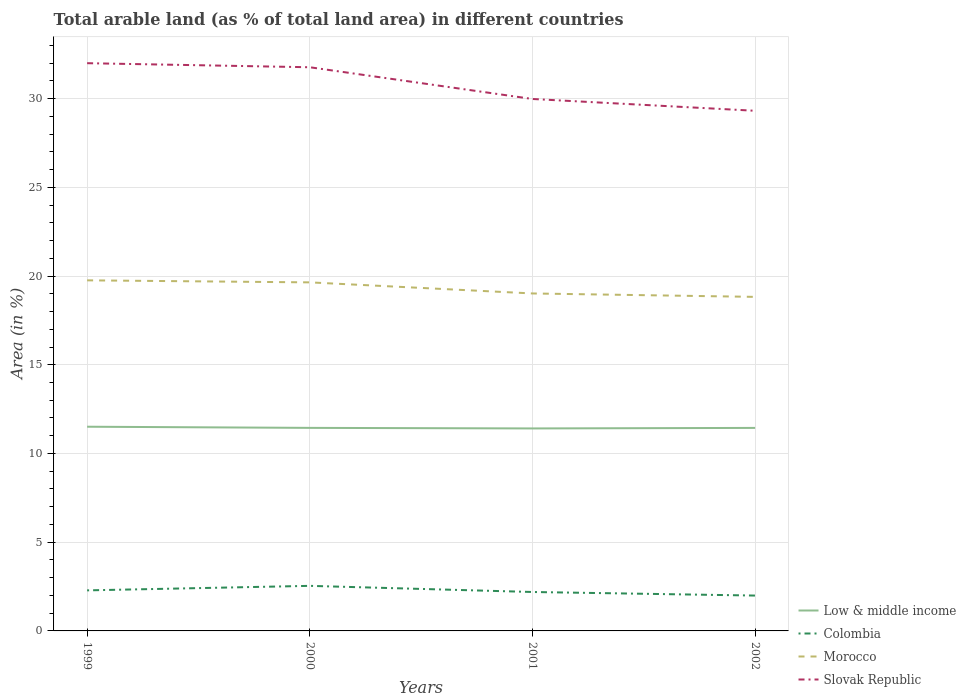How many different coloured lines are there?
Your answer should be compact. 4. Across all years, what is the maximum percentage of arable land in Slovak Republic?
Your response must be concise. 29.31. In which year was the percentage of arable land in Low & middle income maximum?
Give a very brief answer. 2001. What is the total percentage of arable land in Morocco in the graph?
Give a very brief answer. 0.93. What is the difference between the highest and the second highest percentage of arable land in Slovak Republic?
Your response must be concise. 2.68. How many lines are there?
Provide a succinct answer. 4. What is the difference between two consecutive major ticks on the Y-axis?
Offer a terse response. 5. Does the graph contain any zero values?
Provide a short and direct response. No. Does the graph contain grids?
Ensure brevity in your answer.  Yes. How are the legend labels stacked?
Offer a very short reply. Vertical. What is the title of the graph?
Your answer should be compact. Total arable land (as % of total land area) in different countries. Does "Lithuania" appear as one of the legend labels in the graph?
Your response must be concise. No. What is the label or title of the Y-axis?
Your response must be concise. Area (in %). What is the Area (in %) in Low & middle income in 1999?
Provide a short and direct response. 11.51. What is the Area (in %) in Colombia in 1999?
Provide a succinct answer. 2.29. What is the Area (in %) in Morocco in 1999?
Your response must be concise. 19.76. What is the Area (in %) in Slovak Republic in 1999?
Your response must be concise. 32. What is the Area (in %) in Low & middle income in 2000?
Your answer should be compact. 11.44. What is the Area (in %) in Colombia in 2000?
Your answer should be very brief. 2.54. What is the Area (in %) of Morocco in 2000?
Provide a succinct answer. 19.64. What is the Area (in %) of Slovak Republic in 2000?
Your response must be concise. 31.77. What is the Area (in %) of Low & middle income in 2001?
Keep it short and to the point. 11.41. What is the Area (in %) in Colombia in 2001?
Make the answer very short. 2.19. What is the Area (in %) of Morocco in 2001?
Provide a short and direct response. 19.02. What is the Area (in %) in Slovak Republic in 2001?
Offer a terse response. 29.98. What is the Area (in %) in Low & middle income in 2002?
Keep it short and to the point. 11.44. What is the Area (in %) in Colombia in 2002?
Your answer should be very brief. 1.99. What is the Area (in %) of Morocco in 2002?
Give a very brief answer. 18.83. What is the Area (in %) in Slovak Republic in 2002?
Offer a terse response. 29.31. Across all years, what is the maximum Area (in %) of Low & middle income?
Your response must be concise. 11.51. Across all years, what is the maximum Area (in %) of Colombia?
Offer a very short reply. 2.54. Across all years, what is the maximum Area (in %) in Morocco?
Provide a short and direct response. 19.76. Across all years, what is the maximum Area (in %) in Slovak Republic?
Give a very brief answer. 32. Across all years, what is the minimum Area (in %) of Low & middle income?
Offer a terse response. 11.41. Across all years, what is the minimum Area (in %) of Colombia?
Provide a short and direct response. 1.99. Across all years, what is the minimum Area (in %) of Morocco?
Make the answer very short. 18.83. Across all years, what is the minimum Area (in %) in Slovak Republic?
Offer a very short reply. 29.31. What is the total Area (in %) in Low & middle income in the graph?
Provide a short and direct response. 45.8. What is the total Area (in %) of Colombia in the graph?
Make the answer very short. 9.01. What is the total Area (in %) in Morocco in the graph?
Offer a very short reply. 77.25. What is the total Area (in %) in Slovak Republic in the graph?
Offer a very short reply. 123.06. What is the difference between the Area (in %) in Low & middle income in 1999 and that in 2000?
Your answer should be very brief. 0.06. What is the difference between the Area (in %) of Colombia in 1999 and that in 2000?
Offer a terse response. -0.25. What is the difference between the Area (in %) of Morocco in 1999 and that in 2000?
Offer a very short reply. 0.11. What is the difference between the Area (in %) in Slovak Republic in 1999 and that in 2000?
Your response must be concise. 0.23. What is the difference between the Area (in %) in Low & middle income in 1999 and that in 2001?
Your answer should be compact. 0.1. What is the difference between the Area (in %) of Colombia in 1999 and that in 2001?
Your response must be concise. 0.09. What is the difference between the Area (in %) of Morocco in 1999 and that in 2001?
Your answer should be compact. 0.74. What is the difference between the Area (in %) in Slovak Republic in 1999 and that in 2001?
Offer a very short reply. 2.02. What is the difference between the Area (in %) of Low & middle income in 1999 and that in 2002?
Your response must be concise. 0.07. What is the difference between the Area (in %) in Colombia in 1999 and that in 2002?
Make the answer very short. 0.29. What is the difference between the Area (in %) in Morocco in 1999 and that in 2002?
Offer a terse response. 0.93. What is the difference between the Area (in %) in Slovak Republic in 1999 and that in 2002?
Ensure brevity in your answer.  2.68. What is the difference between the Area (in %) in Low & middle income in 2000 and that in 2001?
Provide a succinct answer. 0.03. What is the difference between the Area (in %) in Colombia in 2000 and that in 2001?
Ensure brevity in your answer.  0.35. What is the difference between the Area (in %) of Morocco in 2000 and that in 2001?
Give a very brief answer. 0.63. What is the difference between the Area (in %) in Slovak Republic in 2000 and that in 2001?
Offer a very short reply. 1.79. What is the difference between the Area (in %) in Low & middle income in 2000 and that in 2002?
Provide a succinct answer. 0. What is the difference between the Area (in %) of Colombia in 2000 and that in 2002?
Your response must be concise. 0.55. What is the difference between the Area (in %) of Morocco in 2000 and that in 2002?
Offer a very short reply. 0.82. What is the difference between the Area (in %) of Slovak Republic in 2000 and that in 2002?
Offer a terse response. 2.45. What is the difference between the Area (in %) in Low & middle income in 2001 and that in 2002?
Offer a terse response. -0.03. What is the difference between the Area (in %) in Colombia in 2001 and that in 2002?
Your response must be concise. 0.2. What is the difference between the Area (in %) in Morocco in 2001 and that in 2002?
Your answer should be compact. 0.19. What is the difference between the Area (in %) in Slovak Republic in 2001 and that in 2002?
Your answer should be very brief. 0.67. What is the difference between the Area (in %) in Low & middle income in 1999 and the Area (in %) in Colombia in 2000?
Provide a succinct answer. 8.97. What is the difference between the Area (in %) of Low & middle income in 1999 and the Area (in %) of Morocco in 2000?
Keep it short and to the point. -8.14. What is the difference between the Area (in %) in Low & middle income in 1999 and the Area (in %) in Slovak Republic in 2000?
Offer a terse response. -20.26. What is the difference between the Area (in %) in Colombia in 1999 and the Area (in %) in Morocco in 2000?
Ensure brevity in your answer.  -17.36. What is the difference between the Area (in %) in Colombia in 1999 and the Area (in %) in Slovak Republic in 2000?
Your answer should be compact. -29.48. What is the difference between the Area (in %) of Morocco in 1999 and the Area (in %) of Slovak Republic in 2000?
Provide a succinct answer. -12.01. What is the difference between the Area (in %) in Low & middle income in 1999 and the Area (in %) in Colombia in 2001?
Ensure brevity in your answer.  9.31. What is the difference between the Area (in %) in Low & middle income in 1999 and the Area (in %) in Morocco in 2001?
Make the answer very short. -7.51. What is the difference between the Area (in %) in Low & middle income in 1999 and the Area (in %) in Slovak Republic in 2001?
Your answer should be very brief. -18.47. What is the difference between the Area (in %) of Colombia in 1999 and the Area (in %) of Morocco in 2001?
Provide a short and direct response. -16.73. What is the difference between the Area (in %) of Colombia in 1999 and the Area (in %) of Slovak Republic in 2001?
Keep it short and to the point. -27.69. What is the difference between the Area (in %) in Morocco in 1999 and the Area (in %) in Slovak Republic in 2001?
Offer a terse response. -10.22. What is the difference between the Area (in %) in Low & middle income in 1999 and the Area (in %) in Colombia in 2002?
Your answer should be compact. 9.52. What is the difference between the Area (in %) of Low & middle income in 1999 and the Area (in %) of Morocco in 2002?
Provide a succinct answer. -7.32. What is the difference between the Area (in %) in Low & middle income in 1999 and the Area (in %) in Slovak Republic in 2002?
Your answer should be compact. -17.81. What is the difference between the Area (in %) in Colombia in 1999 and the Area (in %) in Morocco in 2002?
Make the answer very short. -16.54. What is the difference between the Area (in %) of Colombia in 1999 and the Area (in %) of Slovak Republic in 2002?
Provide a short and direct response. -27.03. What is the difference between the Area (in %) of Morocco in 1999 and the Area (in %) of Slovak Republic in 2002?
Offer a terse response. -9.56. What is the difference between the Area (in %) in Low & middle income in 2000 and the Area (in %) in Colombia in 2001?
Give a very brief answer. 9.25. What is the difference between the Area (in %) in Low & middle income in 2000 and the Area (in %) in Morocco in 2001?
Keep it short and to the point. -7.58. What is the difference between the Area (in %) of Low & middle income in 2000 and the Area (in %) of Slovak Republic in 2001?
Give a very brief answer. -18.54. What is the difference between the Area (in %) in Colombia in 2000 and the Area (in %) in Morocco in 2001?
Give a very brief answer. -16.48. What is the difference between the Area (in %) in Colombia in 2000 and the Area (in %) in Slovak Republic in 2001?
Provide a succinct answer. -27.44. What is the difference between the Area (in %) in Morocco in 2000 and the Area (in %) in Slovak Republic in 2001?
Your answer should be very brief. -10.34. What is the difference between the Area (in %) of Low & middle income in 2000 and the Area (in %) of Colombia in 2002?
Give a very brief answer. 9.45. What is the difference between the Area (in %) in Low & middle income in 2000 and the Area (in %) in Morocco in 2002?
Offer a terse response. -7.38. What is the difference between the Area (in %) in Low & middle income in 2000 and the Area (in %) in Slovak Republic in 2002?
Ensure brevity in your answer.  -17.87. What is the difference between the Area (in %) of Colombia in 2000 and the Area (in %) of Morocco in 2002?
Keep it short and to the point. -16.29. What is the difference between the Area (in %) of Colombia in 2000 and the Area (in %) of Slovak Republic in 2002?
Your answer should be compact. -26.77. What is the difference between the Area (in %) of Morocco in 2000 and the Area (in %) of Slovak Republic in 2002?
Your answer should be compact. -9.67. What is the difference between the Area (in %) in Low & middle income in 2001 and the Area (in %) in Colombia in 2002?
Your response must be concise. 9.42. What is the difference between the Area (in %) of Low & middle income in 2001 and the Area (in %) of Morocco in 2002?
Your answer should be very brief. -7.41. What is the difference between the Area (in %) in Low & middle income in 2001 and the Area (in %) in Slovak Republic in 2002?
Offer a terse response. -17.9. What is the difference between the Area (in %) of Colombia in 2001 and the Area (in %) of Morocco in 2002?
Give a very brief answer. -16.63. What is the difference between the Area (in %) in Colombia in 2001 and the Area (in %) in Slovak Republic in 2002?
Give a very brief answer. -27.12. What is the difference between the Area (in %) of Morocco in 2001 and the Area (in %) of Slovak Republic in 2002?
Provide a short and direct response. -10.3. What is the average Area (in %) in Low & middle income per year?
Give a very brief answer. 11.45. What is the average Area (in %) of Colombia per year?
Give a very brief answer. 2.25. What is the average Area (in %) of Morocco per year?
Offer a very short reply. 19.31. What is the average Area (in %) of Slovak Republic per year?
Keep it short and to the point. 30.76. In the year 1999, what is the difference between the Area (in %) in Low & middle income and Area (in %) in Colombia?
Your response must be concise. 9.22. In the year 1999, what is the difference between the Area (in %) in Low & middle income and Area (in %) in Morocco?
Offer a very short reply. -8.25. In the year 1999, what is the difference between the Area (in %) in Low & middle income and Area (in %) in Slovak Republic?
Offer a terse response. -20.49. In the year 1999, what is the difference between the Area (in %) of Colombia and Area (in %) of Morocco?
Offer a terse response. -17.47. In the year 1999, what is the difference between the Area (in %) in Colombia and Area (in %) in Slovak Republic?
Your answer should be very brief. -29.71. In the year 1999, what is the difference between the Area (in %) of Morocco and Area (in %) of Slovak Republic?
Ensure brevity in your answer.  -12.24. In the year 2000, what is the difference between the Area (in %) of Low & middle income and Area (in %) of Colombia?
Ensure brevity in your answer.  8.9. In the year 2000, what is the difference between the Area (in %) in Low & middle income and Area (in %) in Morocco?
Your response must be concise. -8.2. In the year 2000, what is the difference between the Area (in %) of Low & middle income and Area (in %) of Slovak Republic?
Provide a short and direct response. -20.32. In the year 2000, what is the difference between the Area (in %) of Colombia and Area (in %) of Morocco?
Keep it short and to the point. -17.1. In the year 2000, what is the difference between the Area (in %) of Colombia and Area (in %) of Slovak Republic?
Offer a very short reply. -29.23. In the year 2000, what is the difference between the Area (in %) of Morocco and Area (in %) of Slovak Republic?
Offer a terse response. -12.12. In the year 2001, what is the difference between the Area (in %) of Low & middle income and Area (in %) of Colombia?
Give a very brief answer. 9.22. In the year 2001, what is the difference between the Area (in %) of Low & middle income and Area (in %) of Morocco?
Give a very brief answer. -7.61. In the year 2001, what is the difference between the Area (in %) of Low & middle income and Area (in %) of Slovak Republic?
Give a very brief answer. -18.57. In the year 2001, what is the difference between the Area (in %) in Colombia and Area (in %) in Morocco?
Offer a very short reply. -16.82. In the year 2001, what is the difference between the Area (in %) in Colombia and Area (in %) in Slovak Republic?
Ensure brevity in your answer.  -27.79. In the year 2001, what is the difference between the Area (in %) of Morocco and Area (in %) of Slovak Republic?
Provide a short and direct response. -10.96. In the year 2002, what is the difference between the Area (in %) in Low & middle income and Area (in %) in Colombia?
Your response must be concise. 9.45. In the year 2002, what is the difference between the Area (in %) in Low & middle income and Area (in %) in Morocco?
Your answer should be compact. -7.38. In the year 2002, what is the difference between the Area (in %) of Low & middle income and Area (in %) of Slovak Republic?
Your answer should be compact. -17.87. In the year 2002, what is the difference between the Area (in %) of Colombia and Area (in %) of Morocco?
Give a very brief answer. -16.83. In the year 2002, what is the difference between the Area (in %) in Colombia and Area (in %) in Slovak Republic?
Your answer should be very brief. -27.32. In the year 2002, what is the difference between the Area (in %) in Morocco and Area (in %) in Slovak Republic?
Give a very brief answer. -10.49. What is the ratio of the Area (in %) of Low & middle income in 1999 to that in 2000?
Your answer should be very brief. 1.01. What is the ratio of the Area (in %) in Colombia in 1999 to that in 2000?
Your answer should be very brief. 0.9. What is the ratio of the Area (in %) of Morocco in 1999 to that in 2000?
Offer a terse response. 1.01. What is the ratio of the Area (in %) in Slovak Republic in 1999 to that in 2000?
Offer a very short reply. 1.01. What is the ratio of the Area (in %) of Low & middle income in 1999 to that in 2001?
Your response must be concise. 1.01. What is the ratio of the Area (in %) in Colombia in 1999 to that in 2001?
Your answer should be compact. 1.04. What is the ratio of the Area (in %) of Morocco in 1999 to that in 2001?
Provide a short and direct response. 1.04. What is the ratio of the Area (in %) of Slovak Republic in 1999 to that in 2001?
Provide a succinct answer. 1.07. What is the ratio of the Area (in %) in Low & middle income in 1999 to that in 2002?
Provide a succinct answer. 1.01. What is the ratio of the Area (in %) of Colombia in 1999 to that in 2002?
Your answer should be very brief. 1.15. What is the ratio of the Area (in %) in Morocco in 1999 to that in 2002?
Ensure brevity in your answer.  1.05. What is the ratio of the Area (in %) in Slovak Republic in 1999 to that in 2002?
Your answer should be very brief. 1.09. What is the ratio of the Area (in %) in Low & middle income in 2000 to that in 2001?
Make the answer very short. 1. What is the ratio of the Area (in %) of Colombia in 2000 to that in 2001?
Offer a very short reply. 1.16. What is the ratio of the Area (in %) of Morocco in 2000 to that in 2001?
Your answer should be very brief. 1.03. What is the ratio of the Area (in %) in Slovak Republic in 2000 to that in 2001?
Your response must be concise. 1.06. What is the ratio of the Area (in %) of Low & middle income in 2000 to that in 2002?
Keep it short and to the point. 1. What is the ratio of the Area (in %) of Colombia in 2000 to that in 2002?
Provide a short and direct response. 1.27. What is the ratio of the Area (in %) of Morocco in 2000 to that in 2002?
Keep it short and to the point. 1.04. What is the ratio of the Area (in %) in Slovak Republic in 2000 to that in 2002?
Provide a short and direct response. 1.08. What is the ratio of the Area (in %) of Colombia in 2001 to that in 2002?
Your answer should be compact. 1.1. What is the ratio of the Area (in %) of Morocco in 2001 to that in 2002?
Your response must be concise. 1.01. What is the ratio of the Area (in %) of Slovak Republic in 2001 to that in 2002?
Provide a succinct answer. 1.02. What is the difference between the highest and the second highest Area (in %) of Low & middle income?
Offer a very short reply. 0.06. What is the difference between the highest and the second highest Area (in %) in Colombia?
Make the answer very short. 0.25. What is the difference between the highest and the second highest Area (in %) in Morocco?
Your answer should be very brief. 0.11. What is the difference between the highest and the second highest Area (in %) of Slovak Republic?
Ensure brevity in your answer.  0.23. What is the difference between the highest and the lowest Area (in %) of Low & middle income?
Your answer should be compact. 0.1. What is the difference between the highest and the lowest Area (in %) in Colombia?
Provide a short and direct response. 0.55. What is the difference between the highest and the lowest Area (in %) in Morocco?
Make the answer very short. 0.93. What is the difference between the highest and the lowest Area (in %) in Slovak Republic?
Your answer should be compact. 2.68. 